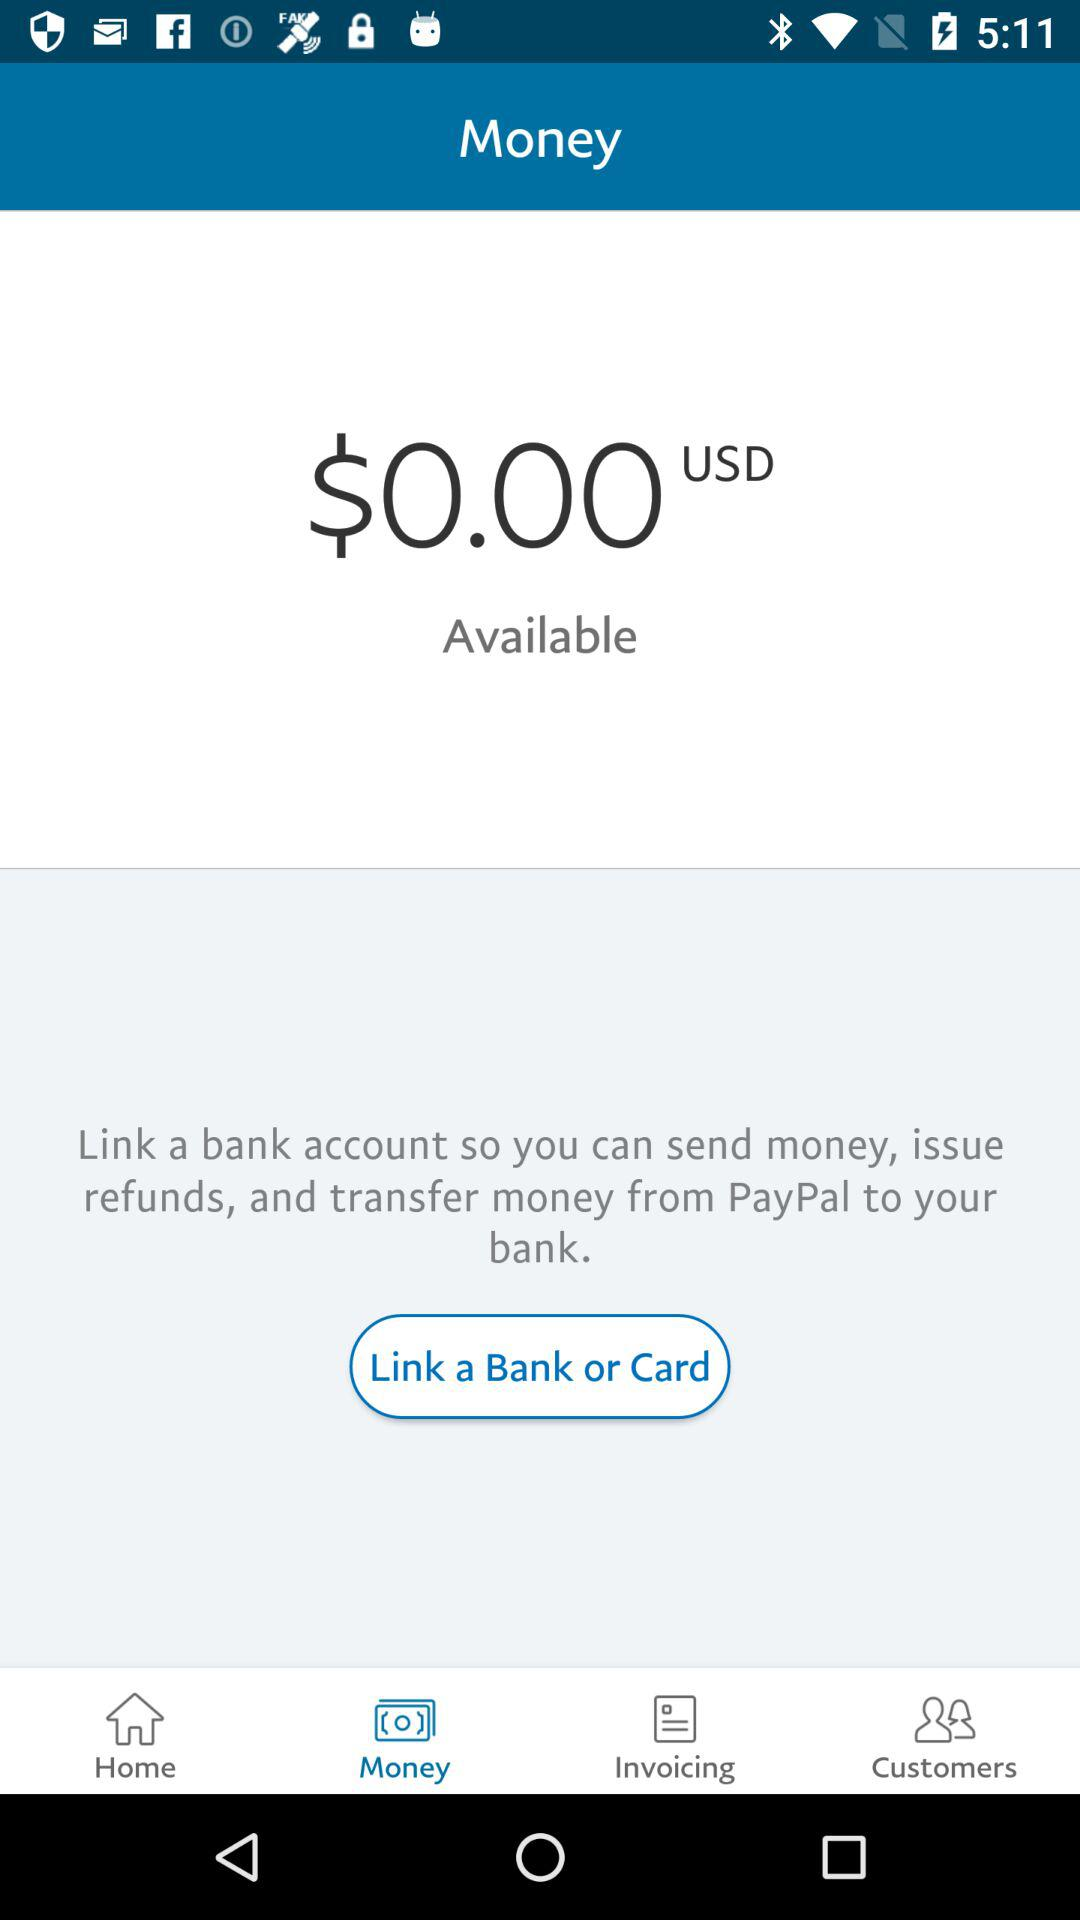Which bank is linked to my account?
When the provided information is insufficient, respond with <no answer>. <no answer> 